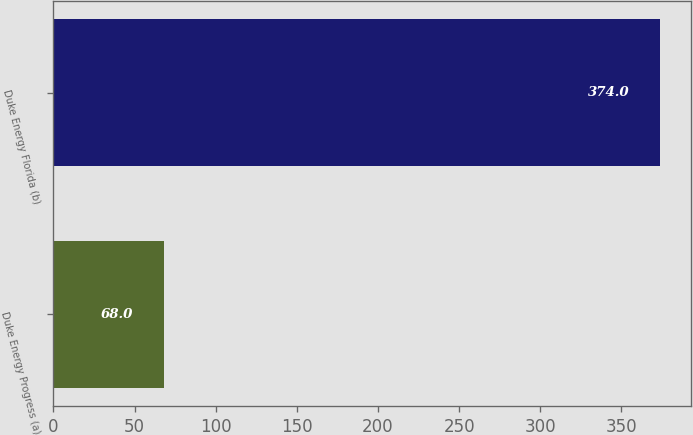Convert chart. <chart><loc_0><loc_0><loc_500><loc_500><bar_chart><fcel>Duke Energy Progress (a)<fcel>Duke Energy Florida (b)<nl><fcel>68<fcel>374<nl></chart> 